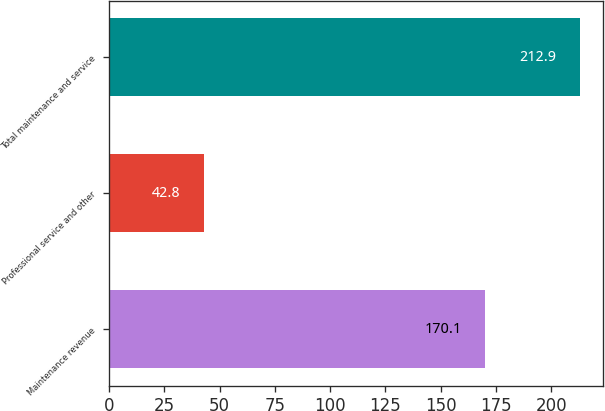Convert chart. <chart><loc_0><loc_0><loc_500><loc_500><bar_chart><fcel>Maintenance revenue<fcel>Professional service and other<fcel>Total maintenance and service<nl><fcel>170.1<fcel>42.8<fcel>212.9<nl></chart> 